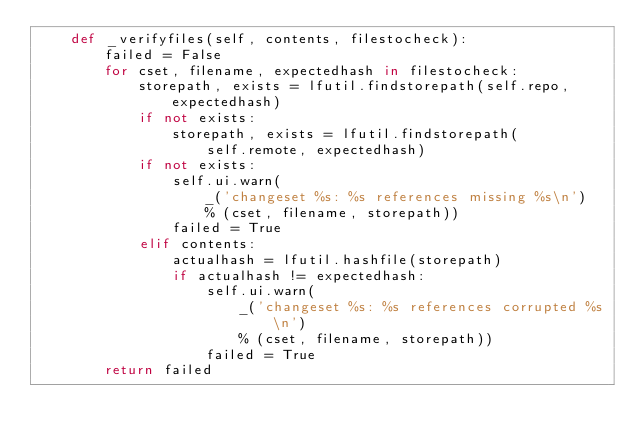Convert code to text. <code><loc_0><loc_0><loc_500><loc_500><_Python_>    def _verifyfiles(self, contents, filestocheck):
        failed = False
        for cset, filename, expectedhash in filestocheck:
            storepath, exists = lfutil.findstorepath(self.repo, expectedhash)
            if not exists:
                storepath, exists = lfutil.findstorepath(
                    self.remote, expectedhash)
            if not exists:
                self.ui.warn(
                    _('changeset %s: %s references missing %s\n')
                    % (cset, filename, storepath))
                failed = True
            elif contents:
                actualhash = lfutil.hashfile(storepath)
                if actualhash != expectedhash:
                    self.ui.warn(
                        _('changeset %s: %s references corrupted %s\n')
                        % (cset, filename, storepath))
                    failed = True
        return failed
</code> 